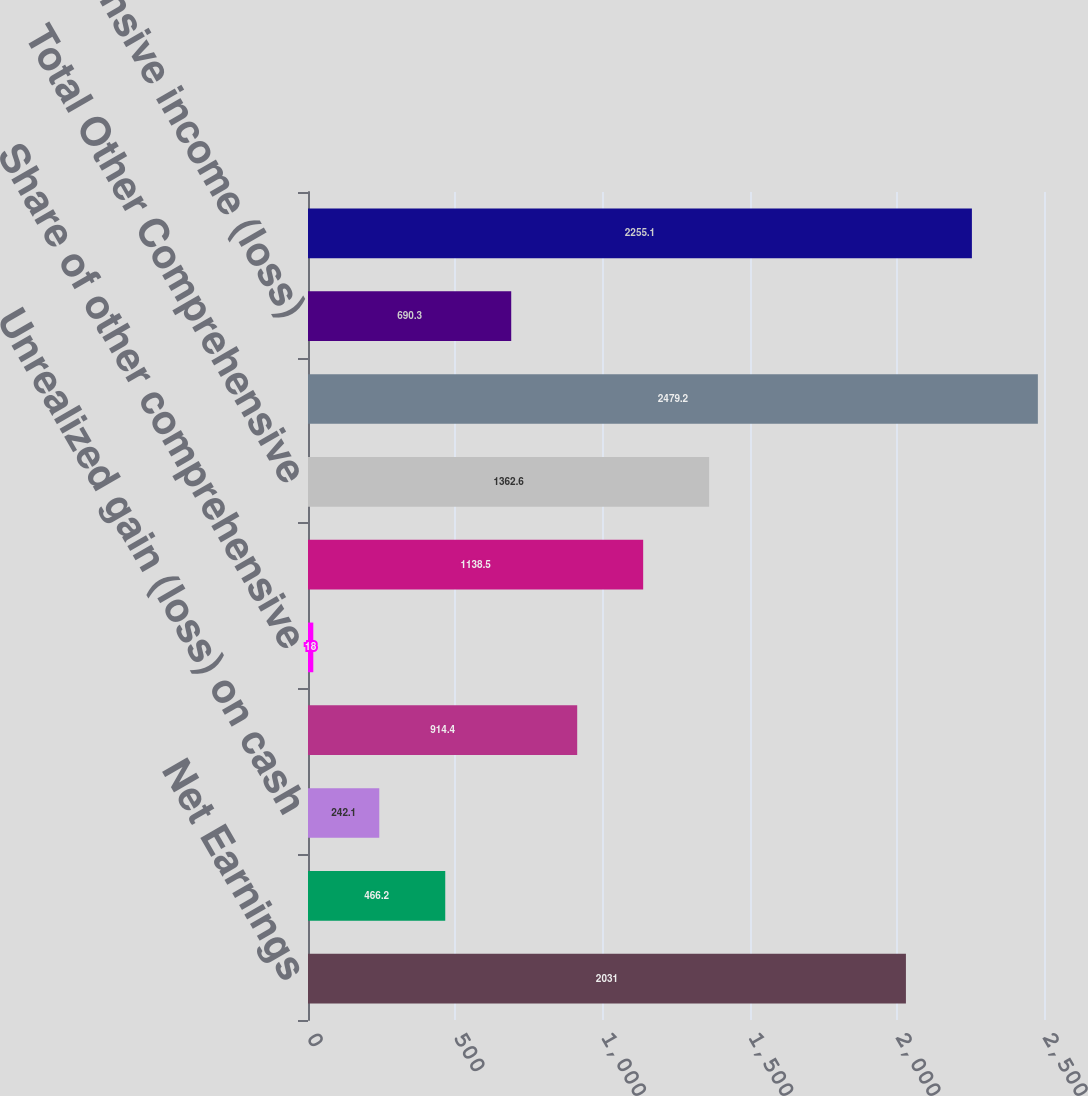Convert chart. <chart><loc_0><loc_0><loc_500><loc_500><bar_chart><fcel>Net Earnings<fcel>Pension/postretirement<fcel>Unrealized gain (loss) on cash<fcel>Unrecognized gain (loss) on<fcel>Share of other comprehensive<fcel>Currency translation<fcel>Total Other Comprehensive<fcel>Total Comprehensive Income<fcel>Comprehensive income (loss)<fcel>Comprehensive Income<nl><fcel>2031<fcel>466.2<fcel>242.1<fcel>914.4<fcel>18<fcel>1138.5<fcel>1362.6<fcel>2479.2<fcel>690.3<fcel>2255.1<nl></chart> 